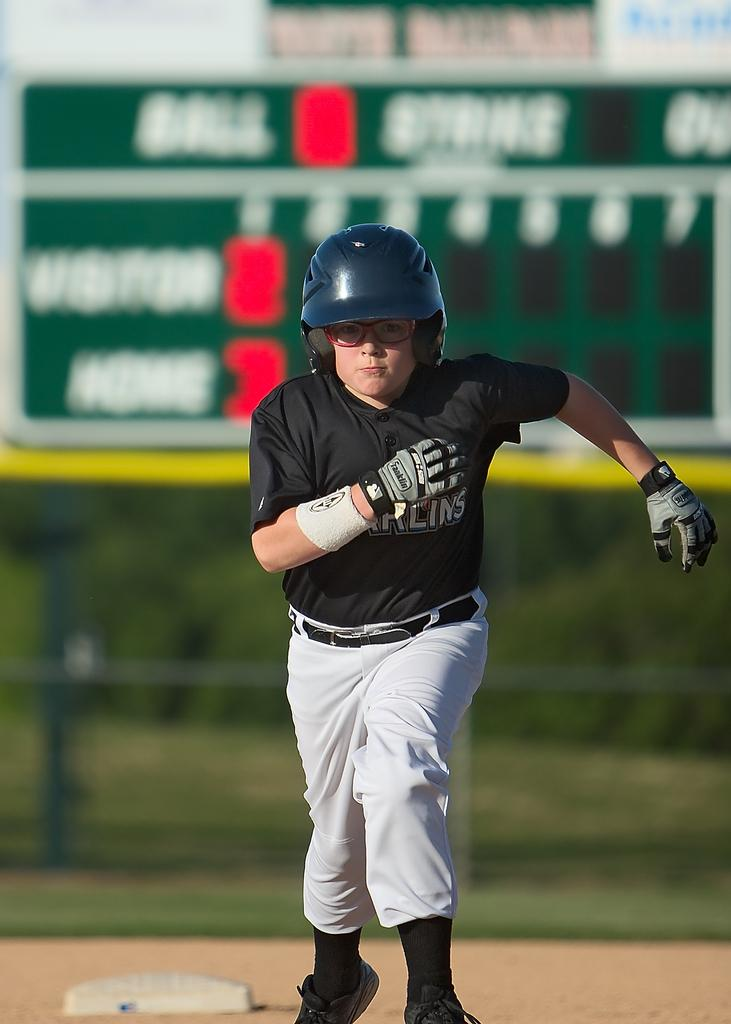<image>
Write a terse but informative summary of the picture. A young boy in a Marlins uniform pours on the steam as he runs the bases. 